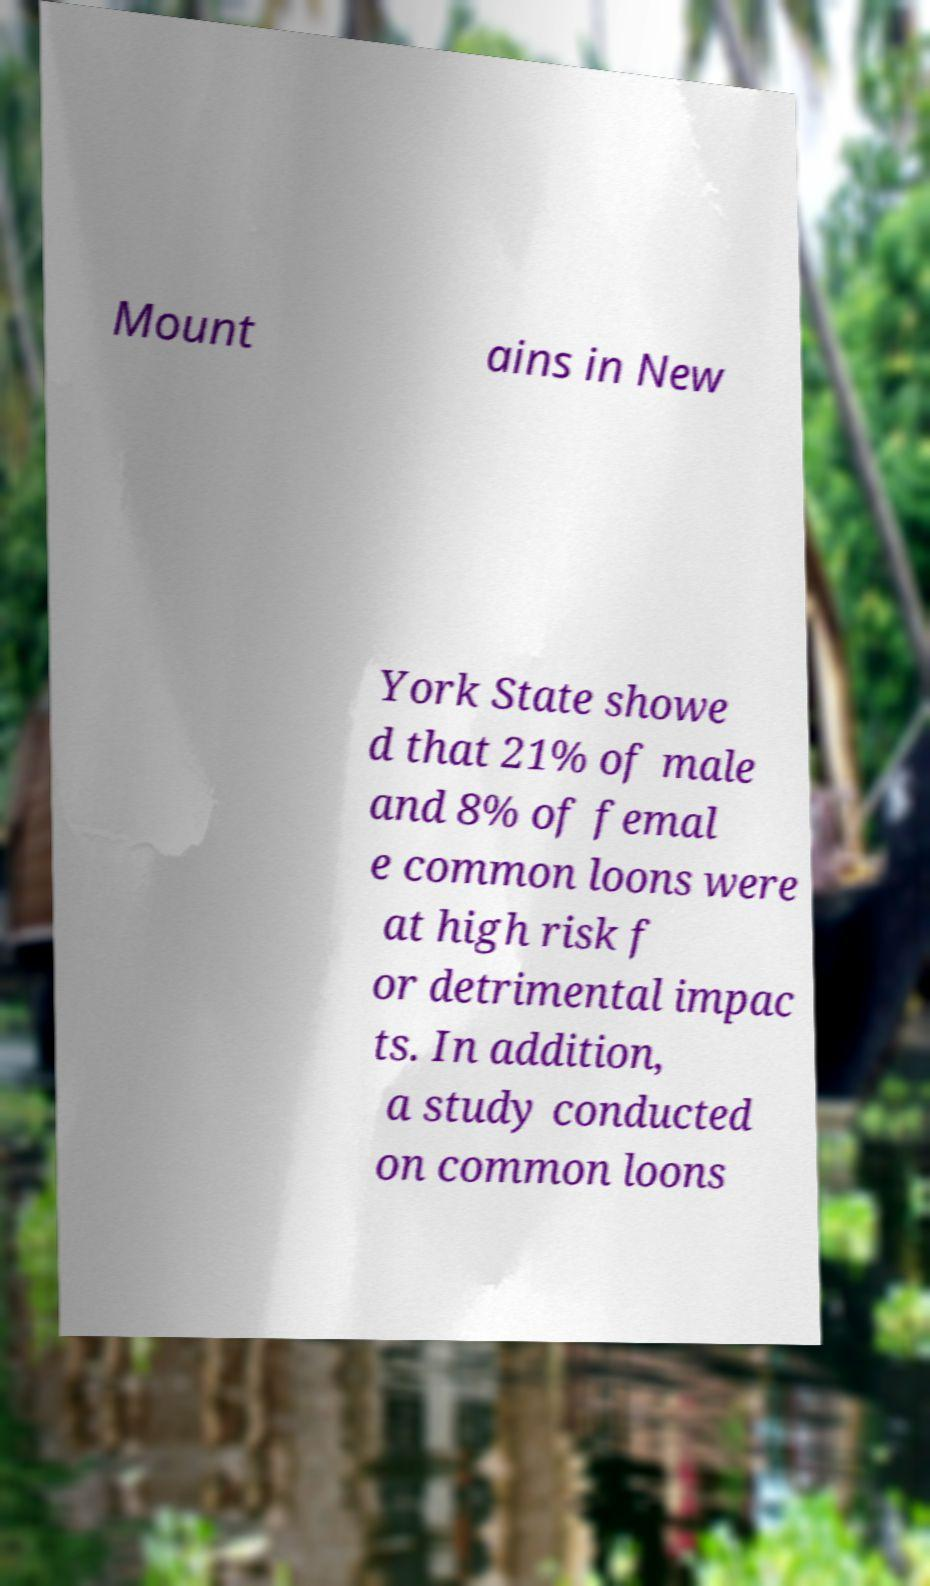Could you extract and type out the text from this image? Mount ains in New York State showe d that 21% of male and 8% of femal e common loons were at high risk f or detrimental impac ts. In addition, a study conducted on common loons 